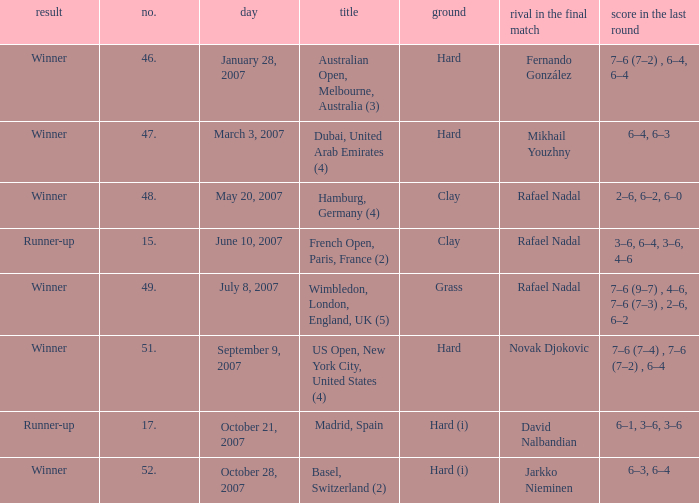On the day october 21, 2007, what is the number? 17.0. 